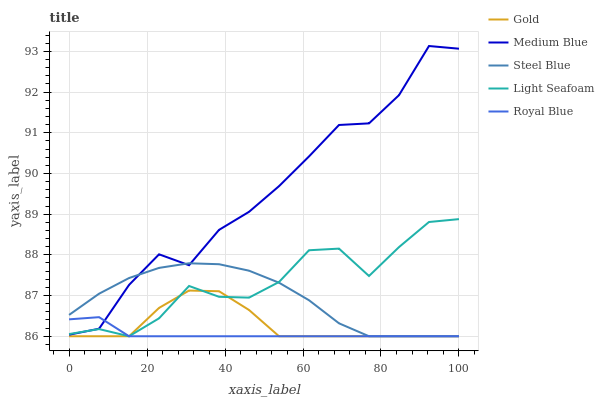Does Royal Blue have the minimum area under the curve?
Answer yes or no. Yes. Does Medium Blue have the maximum area under the curve?
Answer yes or no. Yes. Does Light Seafoam have the minimum area under the curve?
Answer yes or no. No. Does Light Seafoam have the maximum area under the curve?
Answer yes or no. No. Is Royal Blue the smoothest?
Answer yes or no. Yes. Is Medium Blue the roughest?
Answer yes or no. Yes. Is Light Seafoam the smoothest?
Answer yes or no. No. Is Light Seafoam the roughest?
Answer yes or no. No. Does Royal Blue have the lowest value?
Answer yes or no. Yes. Does Medium Blue have the lowest value?
Answer yes or no. No. Does Medium Blue have the highest value?
Answer yes or no. Yes. Does Light Seafoam have the highest value?
Answer yes or no. No. Is Gold less than Medium Blue?
Answer yes or no. Yes. Is Medium Blue greater than Gold?
Answer yes or no. Yes. Does Royal Blue intersect Medium Blue?
Answer yes or no. Yes. Is Royal Blue less than Medium Blue?
Answer yes or no. No. Is Royal Blue greater than Medium Blue?
Answer yes or no. No. Does Gold intersect Medium Blue?
Answer yes or no. No. 